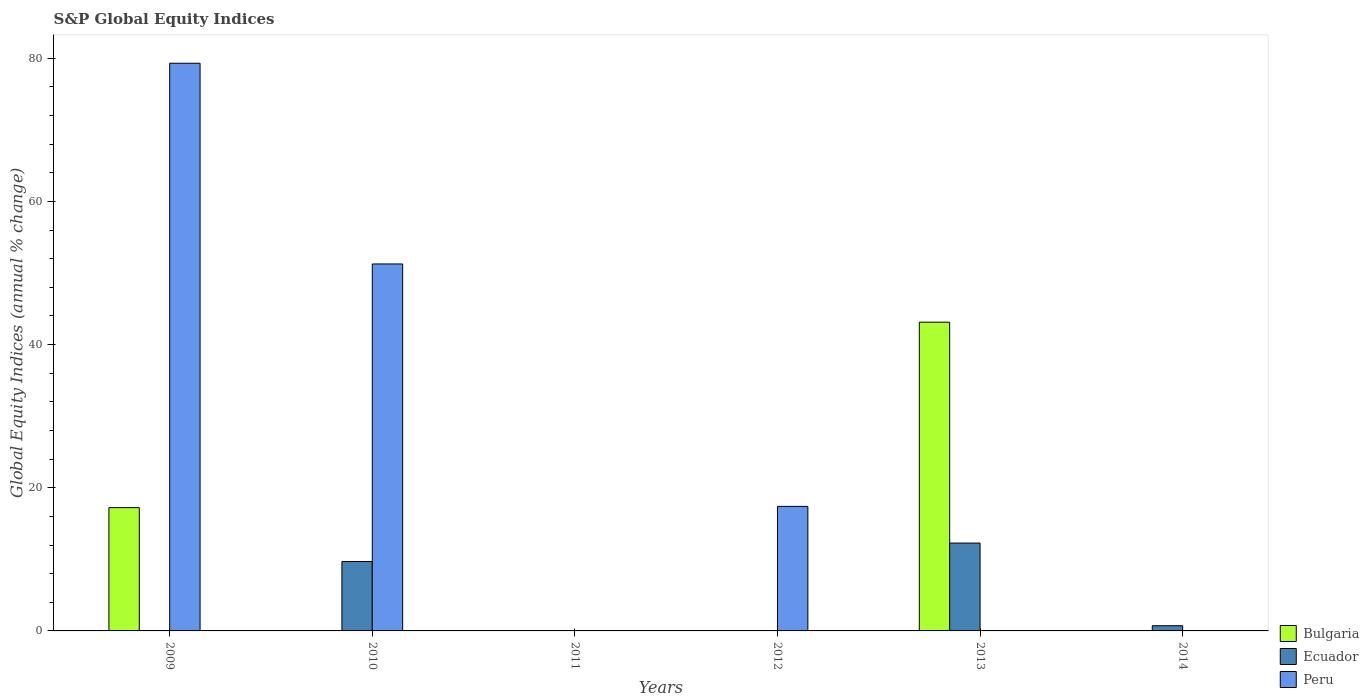How many different coloured bars are there?
Keep it short and to the point. 3. Are the number of bars per tick equal to the number of legend labels?
Your response must be concise. No. Are the number of bars on each tick of the X-axis equal?
Offer a terse response. No. How many bars are there on the 5th tick from the right?
Provide a short and direct response. 2. What is the label of the 2nd group of bars from the left?
Provide a short and direct response. 2010. What is the global equity indices in Ecuador in 2014?
Your answer should be very brief. 0.73. Across all years, what is the maximum global equity indices in Bulgaria?
Your answer should be very brief. 43.13. Across all years, what is the minimum global equity indices in Ecuador?
Your response must be concise. 0. In which year was the global equity indices in Peru maximum?
Your response must be concise. 2009. What is the total global equity indices in Bulgaria in the graph?
Keep it short and to the point. 60.35. What is the difference between the global equity indices in Ecuador in 2010 and that in 2013?
Your response must be concise. -2.58. What is the difference between the global equity indices in Ecuador in 2011 and the global equity indices in Bulgaria in 2013?
Provide a short and direct response. -43.13. What is the average global equity indices in Bulgaria per year?
Your answer should be compact. 10.06. What is the difference between the highest and the second highest global equity indices in Peru?
Offer a very short reply. 28.03. What is the difference between the highest and the lowest global equity indices in Bulgaria?
Provide a short and direct response. 43.13. In how many years, is the global equity indices in Ecuador greater than the average global equity indices in Ecuador taken over all years?
Keep it short and to the point. 2. Is it the case that in every year, the sum of the global equity indices in Bulgaria and global equity indices in Peru is greater than the global equity indices in Ecuador?
Offer a terse response. No. Are all the bars in the graph horizontal?
Ensure brevity in your answer.  No. How many years are there in the graph?
Keep it short and to the point. 6. What is the difference between two consecutive major ticks on the Y-axis?
Your answer should be compact. 20. Are the values on the major ticks of Y-axis written in scientific E-notation?
Provide a short and direct response. No. What is the title of the graph?
Offer a very short reply. S&P Global Equity Indices. What is the label or title of the X-axis?
Offer a terse response. Years. What is the label or title of the Y-axis?
Your answer should be compact. Global Equity Indices (annual % change). What is the Global Equity Indices (annual % change) in Bulgaria in 2009?
Ensure brevity in your answer.  17.22. What is the Global Equity Indices (annual % change) in Ecuador in 2009?
Keep it short and to the point. 0. What is the Global Equity Indices (annual % change) in Peru in 2009?
Your answer should be compact. 79.29. What is the Global Equity Indices (annual % change) in Ecuador in 2010?
Keep it short and to the point. 9.69. What is the Global Equity Indices (annual % change) of Peru in 2010?
Ensure brevity in your answer.  51.26. What is the Global Equity Indices (annual % change) in Bulgaria in 2011?
Provide a short and direct response. 0. What is the Global Equity Indices (annual % change) of Bulgaria in 2012?
Provide a succinct answer. 0. What is the Global Equity Indices (annual % change) of Peru in 2012?
Your response must be concise. 17.39. What is the Global Equity Indices (annual % change) of Bulgaria in 2013?
Make the answer very short. 43.13. What is the Global Equity Indices (annual % change) of Ecuador in 2013?
Give a very brief answer. 12.27. What is the Global Equity Indices (annual % change) in Peru in 2013?
Your answer should be compact. 0. What is the Global Equity Indices (annual % change) in Bulgaria in 2014?
Give a very brief answer. 0. What is the Global Equity Indices (annual % change) of Ecuador in 2014?
Keep it short and to the point. 0.73. Across all years, what is the maximum Global Equity Indices (annual % change) of Bulgaria?
Your answer should be compact. 43.13. Across all years, what is the maximum Global Equity Indices (annual % change) in Ecuador?
Ensure brevity in your answer.  12.27. Across all years, what is the maximum Global Equity Indices (annual % change) of Peru?
Offer a terse response. 79.29. Across all years, what is the minimum Global Equity Indices (annual % change) of Ecuador?
Ensure brevity in your answer.  0. What is the total Global Equity Indices (annual % change) in Bulgaria in the graph?
Your answer should be very brief. 60.35. What is the total Global Equity Indices (annual % change) of Ecuador in the graph?
Make the answer very short. 22.69. What is the total Global Equity Indices (annual % change) in Peru in the graph?
Provide a succinct answer. 147.94. What is the difference between the Global Equity Indices (annual % change) of Peru in 2009 and that in 2010?
Provide a succinct answer. 28.03. What is the difference between the Global Equity Indices (annual % change) of Peru in 2009 and that in 2012?
Keep it short and to the point. 61.9. What is the difference between the Global Equity Indices (annual % change) of Bulgaria in 2009 and that in 2013?
Keep it short and to the point. -25.9. What is the difference between the Global Equity Indices (annual % change) in Peru in 2010 and that in 2012?
Provide a succinct answer. 33.87. What is the difference between the Global Equity Indices (annual % change) in Ecuador in 2010 and that in 2013?
Provide a short and direct response. -2.58. What is the difference between the Global Equity Indices (annual % change) in Ecuador in 2010 and that in 2014?
Your response must be concise. 8.97. What is the difference between the Global Equity Indices (annual % change) of Ecuador in 2013 and that in 2014?
Your response must be concise. 11.55. What is the difference between the Global Equity Indices (annual % change) of Bulgaria in 2009 and the Global Equity Indices (annual % change) of Ecuador in 2010?
Make the answer very short. 7.53. What is the difference between the Global Equity Indices (annual % change) in Bulgaria in 2009 and the Global Equity Indices (annual % change) in Peru in 2010?
Your response must be concise. -34.04. What is the difference between the Global Equity Indices (annual % change) in Bulgaria in 2009 and the Global Equity Indices (annual % change) in Peru in 2012?
Make the answer very short. -0.17. What is the difference between the Global Equity Indices (annual % change) in Bulgaria in 2009 and the Global Equity Indices (annual % change) in Ecuador in 2013?
Provide a short and direct response. 4.95. What is the difference between the Global Equity Indices (annual % change) of Bulgaria in 2009 and the Global Equity Indices (annual % change) of Ecuador in 2014?
Make the answer very short. 16.5. What is the difference between the Global Equity Indices (annual % change) of Ecuador in 2010 and the Global Equity Indices (annual % change) of Peru in 2012?
Make the answer very short. -7.7. What is the difference between the Global Equity Indices (annual % change) of Bulgaria in 2013 and the Global Equity Indices (annual % change) of Ecuador in 2014?
Provide a succinct answer. 42.4. What is the average Global Equity Indices (annual % change) in Bulgaria per year?
Make the answer very short. 10.06. What is the average Global Equity Indices (annual % change) in Ecuador per year?
Give a very brief answer. 3.78. What is the average Global Equity Indices (annual % change) in Peru per year?
Provide a succinct answer. 24.66. In the year 2009, what is the difference between the Global Equity Indices (annual % change) of Bulgaria and Global Equity Indices (annual % change) of Peru?
Provide a succinct answer. -62.07. In the year 2010, what is the difference between the Global Equity Indices (annual % change) in Ecuador and Global Equity Indices (annual % change) in Peru?
Offer a terse response. -41.56. In the year 2013, what is the difference between the Global Equity Indices (annual % change) of Bulgaria and Global Equity Indices (annual % change) of Ecuador?
Your response must be concise. 30.85. What is the ratio of the Global Equity Indices (annual % change) in Peru in 2009 to that in 2010?
Your answer should be compact. 1.55. What is the ratio of the Global Equity Indices (annual % change) of Peru in 2009 to that in 2012?
Make the answer very short. 4.56. What is the ratio of the Global Equity Indices (annual % change) of Bulgaria in 2009 to that in 2013?
Give a very brief answer. 0.4. What is the ratio of the Global Equity Indices (annual % change) of Peru in 2010 to that in 2012?
Offer a very short reply. 2.95. What is the ratio of the Global Equity Indices (annual % change) of Ecuador in 2010 to that in 2013?
Make the answer very short. 0.79. What is the ratio of the Global Equity Indices (annual % change) in Ecuador in 2010 to that in 2014?
Provide a short and direct response. 13.34. What is the ratio of the Global Equity Indices (annual % change) in Ecuador in 2013 to that in 2014?
Provide a short and direct response. 16.89. What is the difference between the highest and the second highest Global Equity Indices (annual % change) of Ecuador?
Offer a very short reply. 2.58. What is the difference between the highest and the second highest Global Equity Indices (annual % change) of Peru?
Provide a short and direct response. 28.03. What is the difference between the highest and the lowest Global Equity Indices (annual % change) of Bulgaria?
Your answer should be very brief. 43.13. What is the difference between the highest and the lowest Global Equity Indices (annual % change) in Ecuador?
Give a very brief answer. 12.27. What is the difference between the highest and the lowest Global Equity Indices (annual % change) in Peru?
Provide a succinct answer. 79.29. 